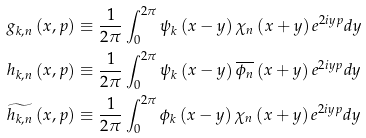Convert formula to latex. <formula><loc_0><loc_0><loc_500><loc_500>g _ { k , n } \left ( x , p \right ) & \equiv \frac { 1 } { 2 \pi } \int _ { 0 } ^ { 2 \pi } \psi _ { k } \left ( x - y \right ) \chi _ { n } \left ( x + y \right ) e ^ { 2 i y p } d y \\ h _ { k , n } \left ( x , p \right ) & \equiv \frac { 1 } { 2 \pi } \int _ { 0 } ^ { 2 \pi } \psi _ { k } \left ( x - y \right ) \overline { \phi _ { n } } \left ( x + y \right ) e ^ { 2 i y p } d y \\ \widetilde { h _ { k , n } } \left ( x , p \right ) & \equiv \frac { 1 } { 2 \pi } \int _ { 0 } ^ { 2 \pi } \phi _ { k } \left ( x - y \right ) \chi _ { n } \left ( x + y \right ) e ^ { 2 i y p } d y</formula> 